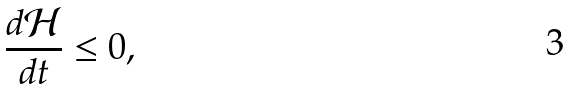<formula> <loc_0><loc_0><loc_500><loc_500>\frac { d \mathcal { H } } { d t } \leq 0 ,</formula> 